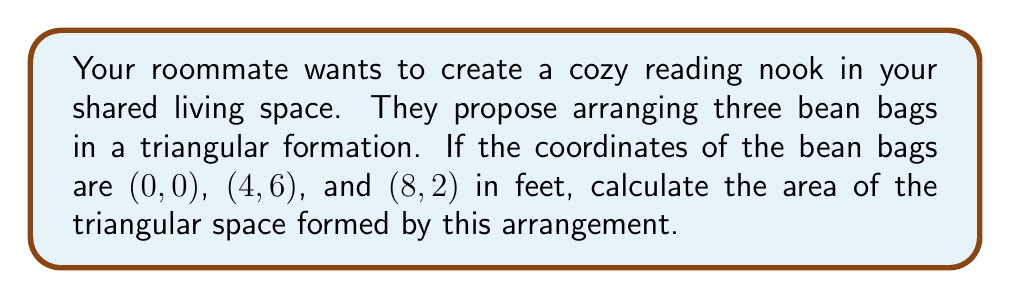Show me your answer to this math problem. To calculate the area of a triangle using coordinate geometry, we can use the formula:

$$\text{Area} = \frac{1}{2}|x_1(y_2 - y_3) + x_2(y_3 - y_1) + x_3(y_1 - y_2)|$$

Where $(x_1, y_1)$, $(x_2, y_2)$, and $(x_3, y_3)$ are the coordinates of the three vertices.

Let's assign our coordinates:
$(x_1, y_1) = (0, 0)$
$(x_2, y_2) = (4, 6)$
$(x_3, y_3) = (8, 2)$

Now, let's substitute these into our formula:

$$\begin{align*}
\text{Area} &= \frac{1}{2}|0(6 - 2) + 4(2 - 0) + 8(0 - 6)|\\
&= \frac{1}{2}|0(4) + 4(2) + 8(-6)|\\
&= \frac{1}{2}|0 + 8 - 48|\\
&= \frac{1}{2}|-40|\\
&= \frac{1}{2}(40)\\
&= 20
\end{align*}$$

Therefore, the area of the triangular space is 20 square feet.

[asy]
unitsize(0.5cm);
draw((0,0)--(4,6)--(8,2)--cycle);
dot((0,0));
dot((4,6));
dot((8,2));
label("(0,0)", (0,0), SW);
label("(4,6)", (4,6), N);
label("(8,2)", (8,2), SE);
[/asy]
Answer: 20 sq ft 